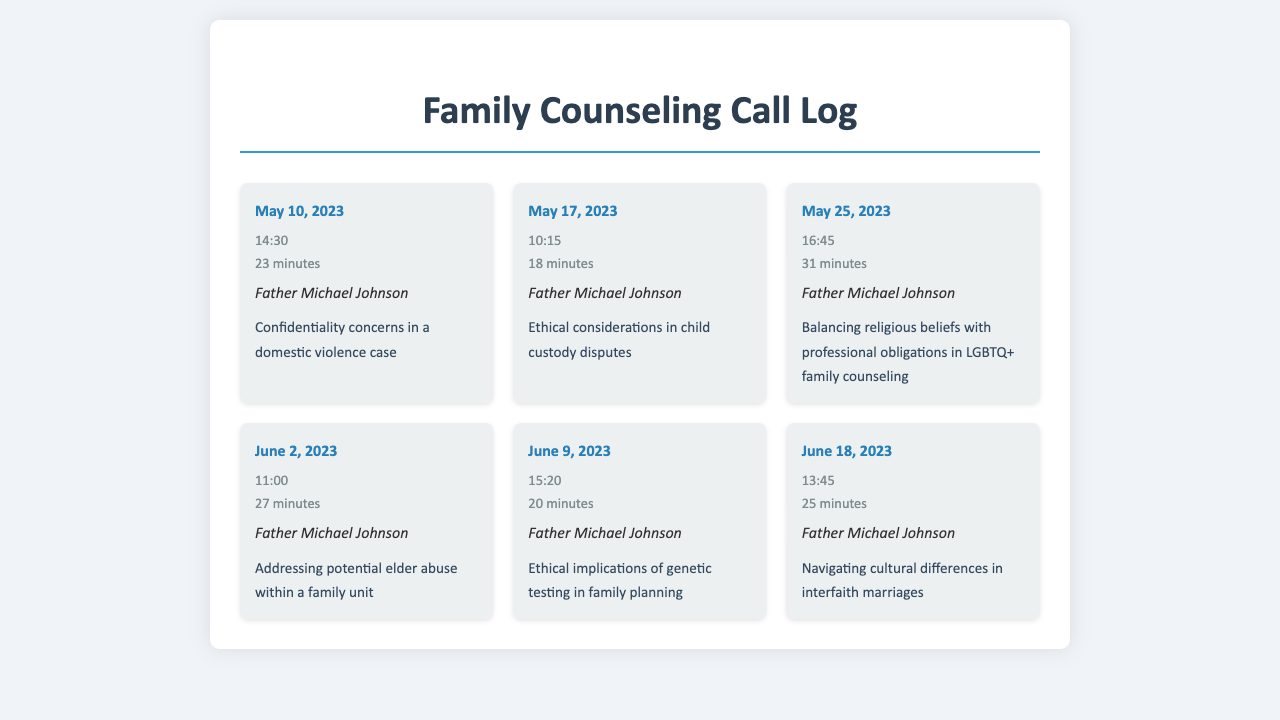What is the date of the first call? The first call in the log is dated May 10, 2023.
Answer: May 10, 2023 Who is the contact person for all calls? The contact person for all calls listed is Father Michael Johnson.
Answer: Father Michael Johnson What was the duration of the call on May 25, 2023? The duration of the call on May 25, 2023, is mentioned as 31 minutes.
Answer: 31 minutes What ethical topic was discussed on June 9, 2023? The call on June 9, 2023, covered the topic of ethical implications of genetic testing in family planning.
Answer: Ethical implications of genetic testing in family planning How many minutes was the call addressing cultural differences? The call addressing cultural differences in interfaith marriages lasted for 25 minutes.
Answer: 25 minutes Which call focused on elder abuse? The call on June 2, 2023, specifically addressed potential elder abuse within a family unit.
Answer: June 2, 2023 How many calls were made in May 2023? There were three calls made in May 2023, specifically on the 10th, 17th, and 25th.
Answer: Three calls What time was the call regarding child custody disputes? The call discussing ethical considerations in child custody disputes was made at 10:15.
Answer: 10:15 What is the main concern in the first call? The main concern discussed in the first call was confidentiality in a domestic violence case.
Answer: Confidentiality concerns in a domestic violence case 